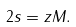Convert formula to latex. <formula><loc_0><loc_0><loc_500><loc_500>2 s = z M .</formula> 